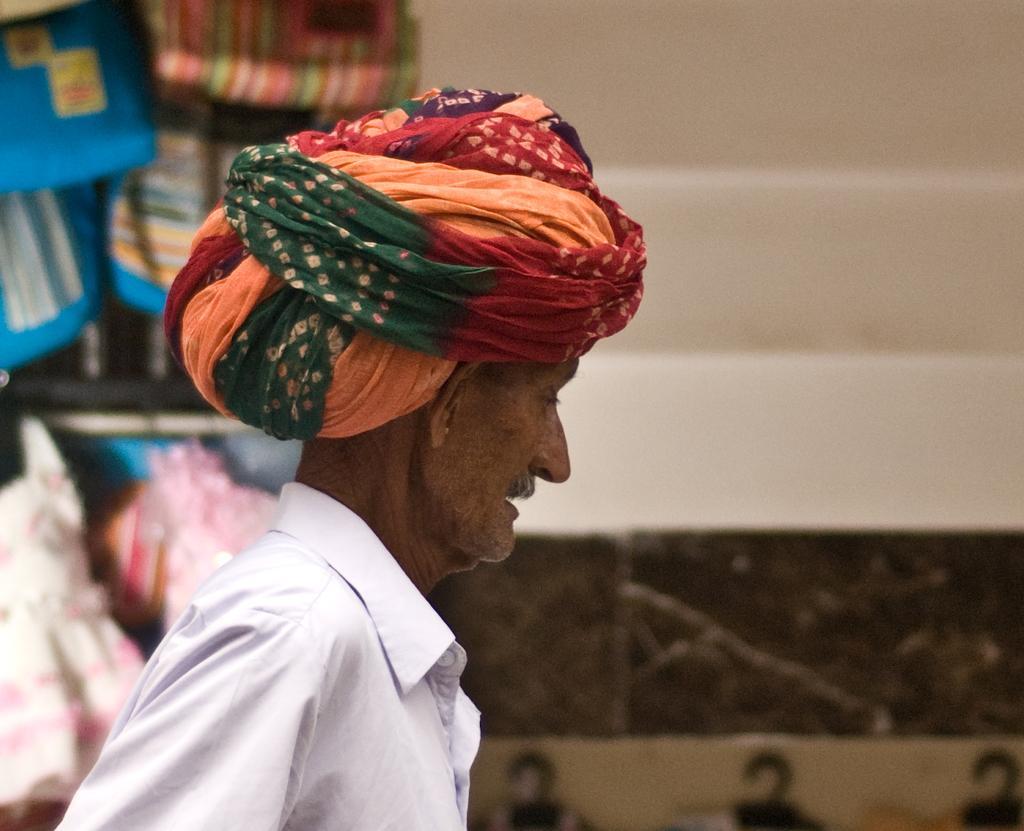In one or two sentences, can you explain what this image depicts? In this picture we can see a person and in the background we can see some objects. 